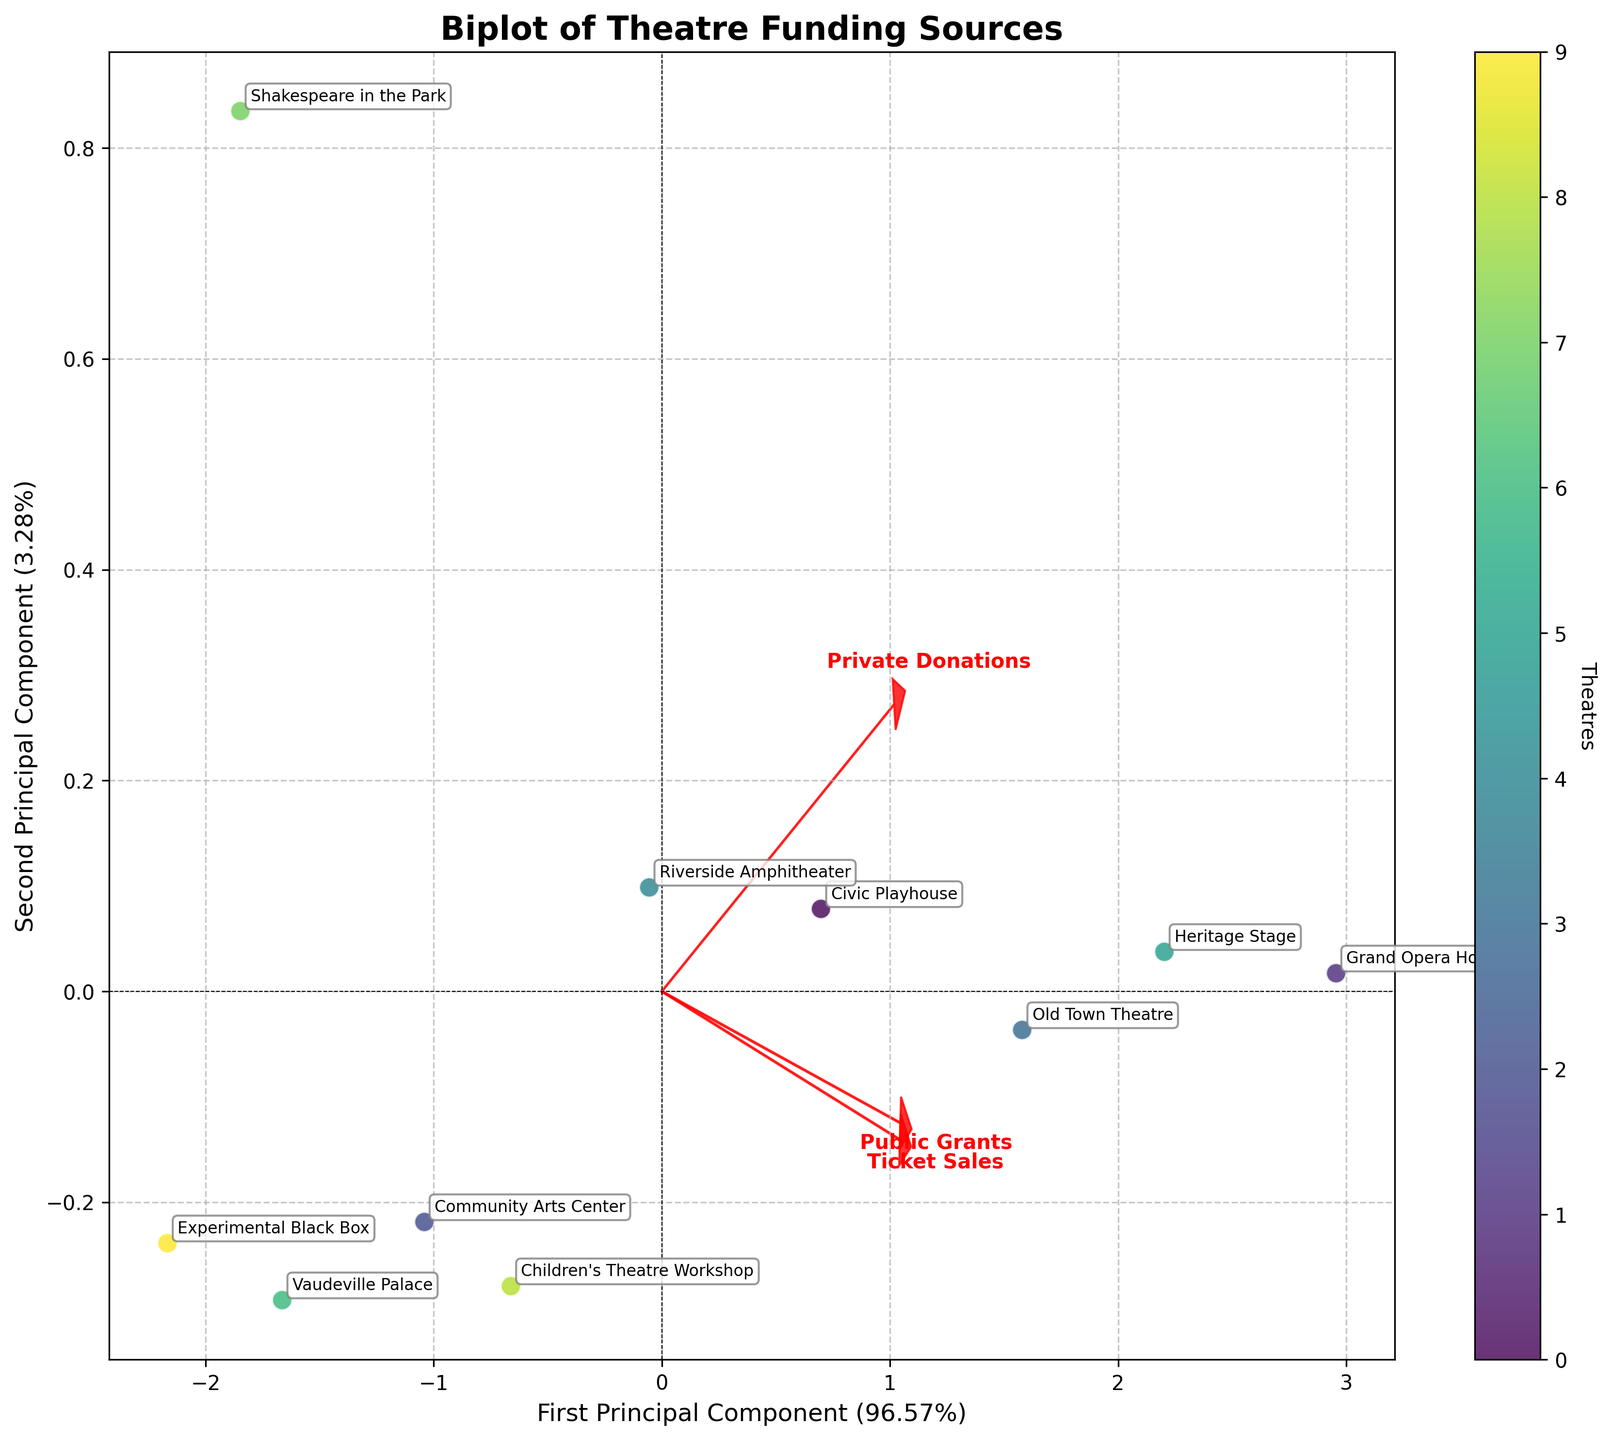1. What is the title of the plot? The title is usually prominently displayed at the top of the plot. For this plot, it reads "Biplot of Theatre Funding Sources".
Answer: Biplot of Theatre Funding Sources 2. How many principal components are shown in the plot? The plot shows two components, which are indicated on the x-axis and y-axis as the First and Second Principal Components.
Answer: Two 3. Which theatre appears to have the highest ticket sales in relation to the principal components? By looking at the position of the theatres in relation to the vector representing 'Ticket Sales', we see that "Grand Opera House" is closest to the direction of the 'Ticket Sales' vector.
Answer: Grand Opera House 4. Which funding source contributes most significantly to the first principal component? The vector most aligned with the x-axis (First Principal Component) shows the highest contribution. In this case, 'Ticket Sales' appears most aligned with the x-axis.
Answer: Ticket Sales 5. Are public grants and private donations positively or negatively correlated on the biplot? We see the vectors for 'Public Grants' and 'Private Donations'. Since they point in roughly similar directions from the origin, they are positively correlated.
Answer: Positively correlated 6. How does the 'Shakespeare in the Park' compare with other theatres in terms of private donations? 'Shakespeare in the Park' should be evaluated based on its position along the 'Private Donations' vector. It appears relatively further away, indicating lower private donations compared to others like 'Grand Opera House' and 'Heritage Stage'.
Answer: Lower private donations 7. Which principal component explains more of the variance in the data? The axis labels show the percentages each principal component explains of the variance. The First Principal Component has a higher percentage (component with ~57%) than the Second Principal Component (component with ~30%).
Answer: First Principal Component 8. If a theatre is located more towards the top-right of the biplot, how would you describe its overall funding? The top-right direction generally increases along both principal components, influenced by all three funding sources. Hence, theatres in the top-right area would receive high levels of funding from all sources.
Answer: High overall funding 9. What is the role of the red arrows in the plot? The red arrows represent the directions and magnitudes of each funding source's contribution to the principal components, helping to understand the influence of each source on the position of the theatres.
Answer: Directions and magnitudes of funding sources 10. Which theatre is the most balanced in terms of funding sources? Theatres close to the origin and equidistant from all vectors indicate balanced funding. 'Experimental Black Box' appears to be the closest to the origin, suggesting balanced contributions from all funding sources.
Answer: Experimental Black Box 